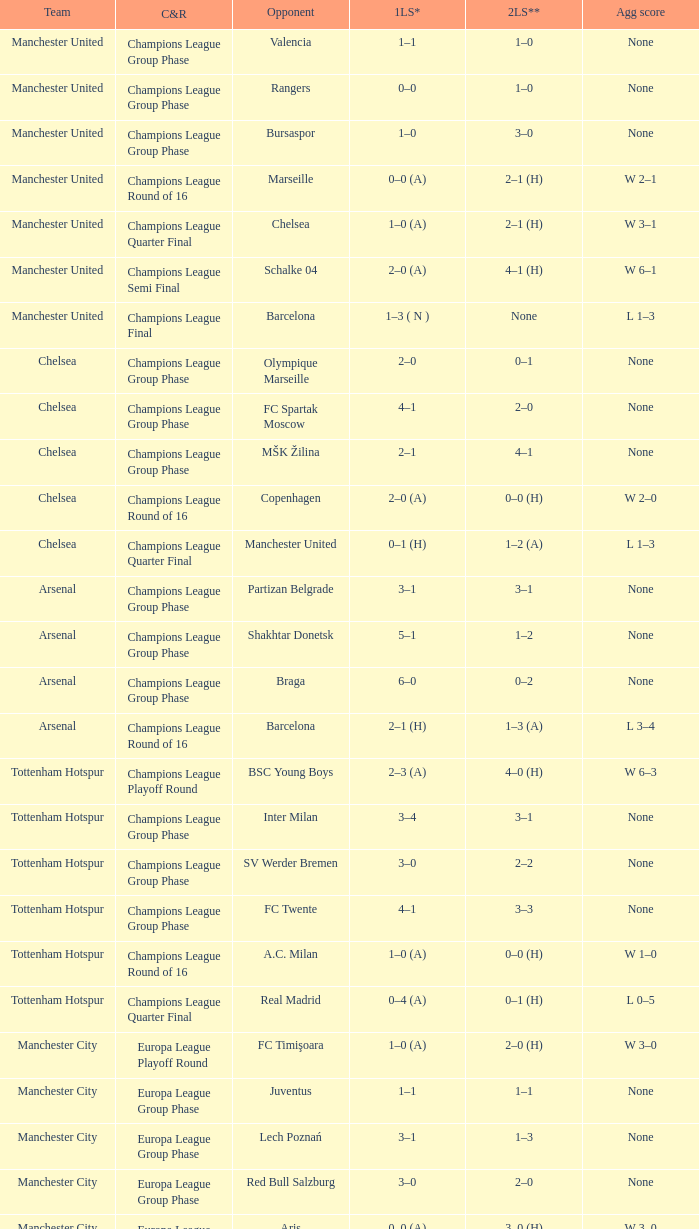How many goals did each one of the teams score in the first leg of the match between Liverpool and Trabzonspor? 1–0 (H). 